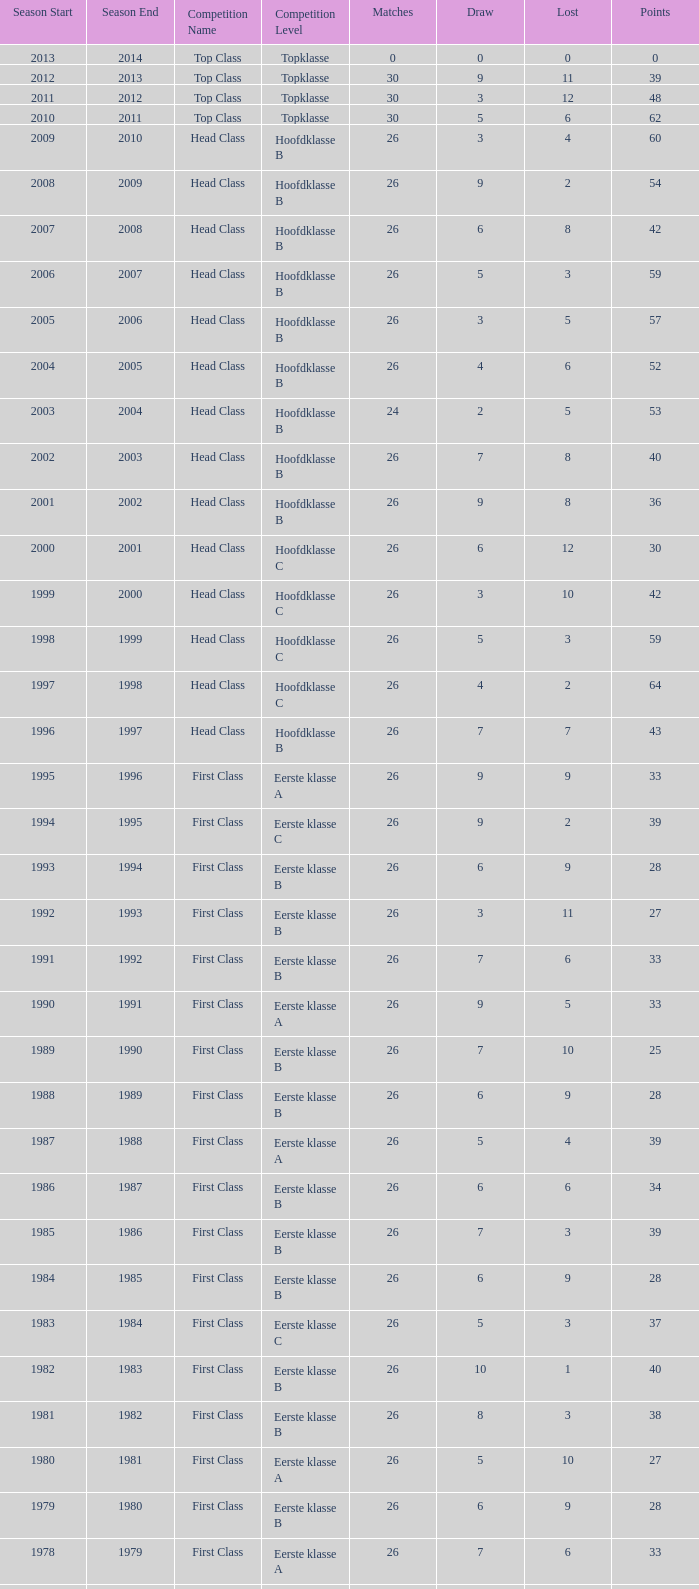What is the total number of matches with a loss less than 5 in the 2008/2009 season and has a draw larger than 9? 0.0. 